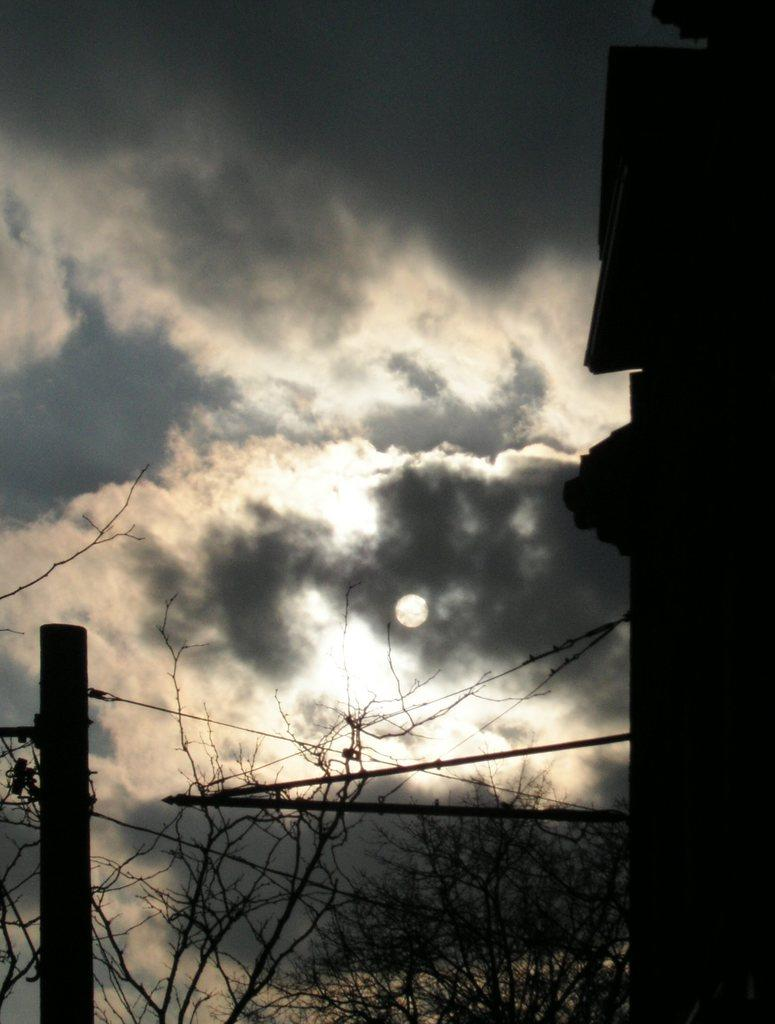What natural element is visible in the image? The sky is visible in the image. What can be seen in the sky in the image? Clouds are present in the image. What type of vegetation is visible in the image? Trees are visible in the image. What celestial body is observable in the image? The moon is observable in the image. What man-made object is present in the image? There is a pole in the image. What architectural feature is present in the image? A wall is present in the image. What type of music can be heard playing in the image? There is no music present in the image, as it is a still image and not a video or audio recording. What color is the paint on the wall in the image? There is no paint visible in the image, as the wall appears to be a natural material such as stone or brick. 